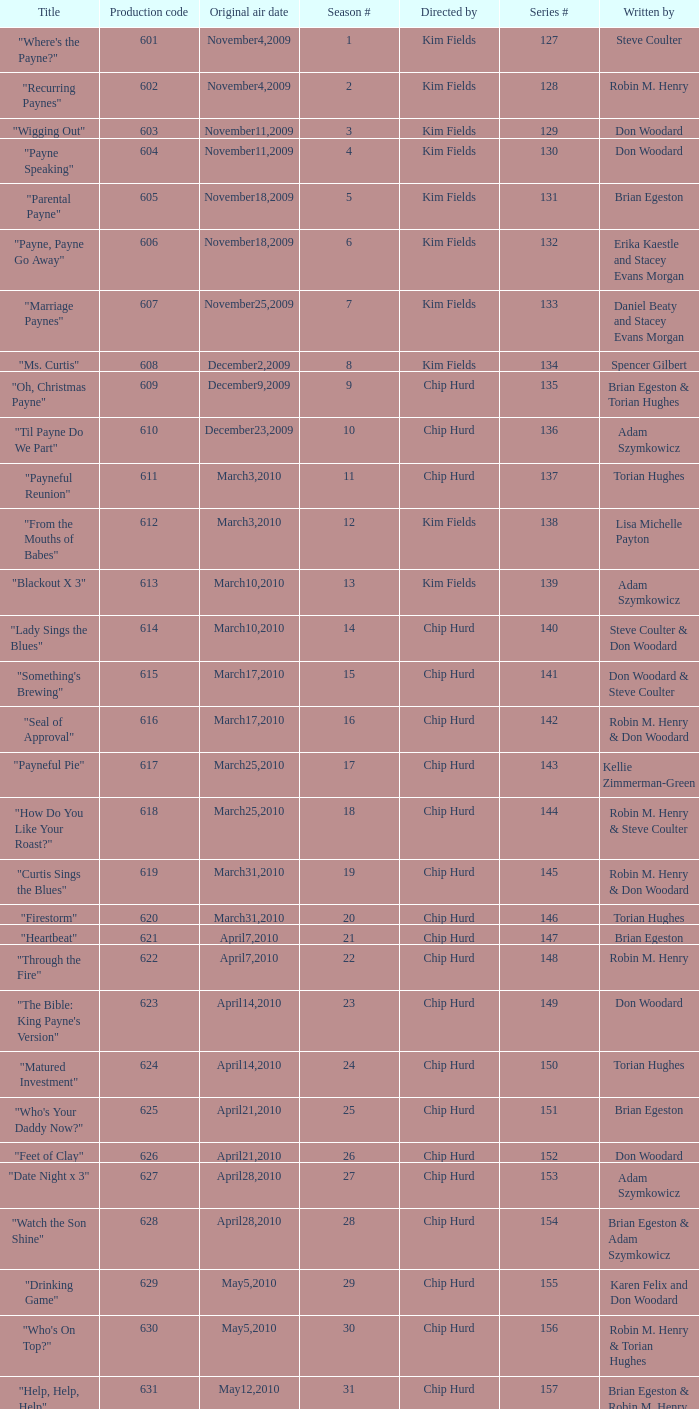What is the original air date of the episode written by Karen Felix and Don Woodard? May5,2010. 